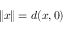<formula> <loc_0><loc_0><loc_500><loc_500>\| x \| = d ( x , 0 )</formula> 